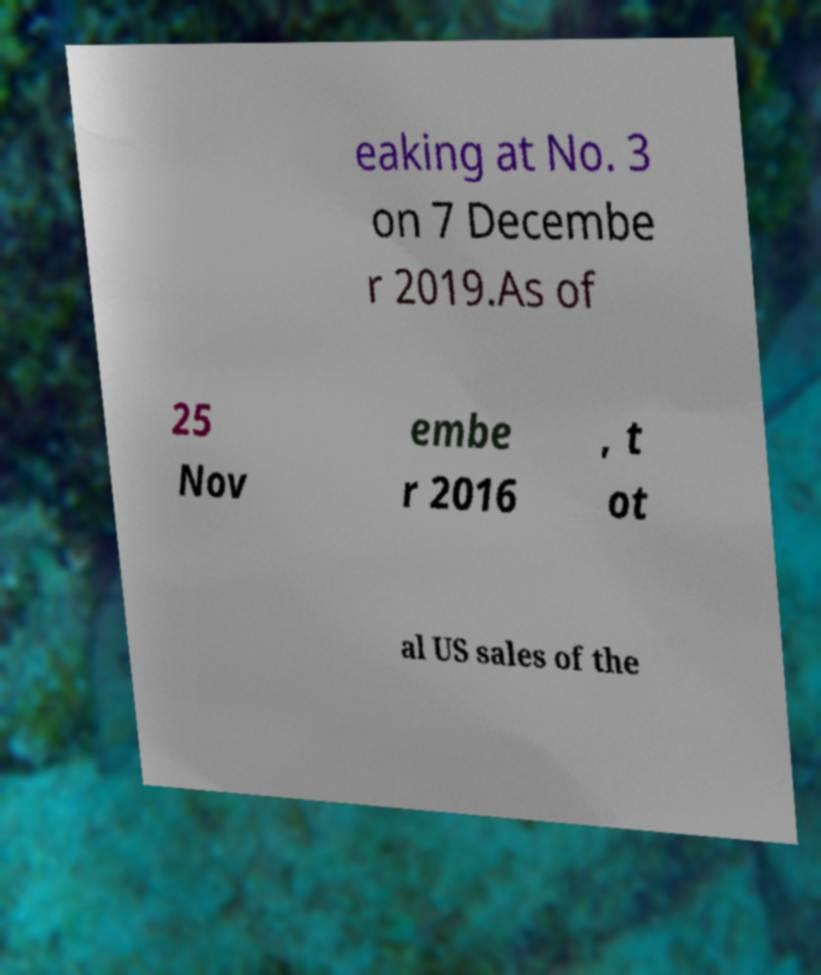There's text embedded in this image that I need extracted. Can you transcribe it verbatim? eaking at No. 3 on 7 Decembe r 2019.As of 25 Nov embe r 2016 , t ot al US sales of the 